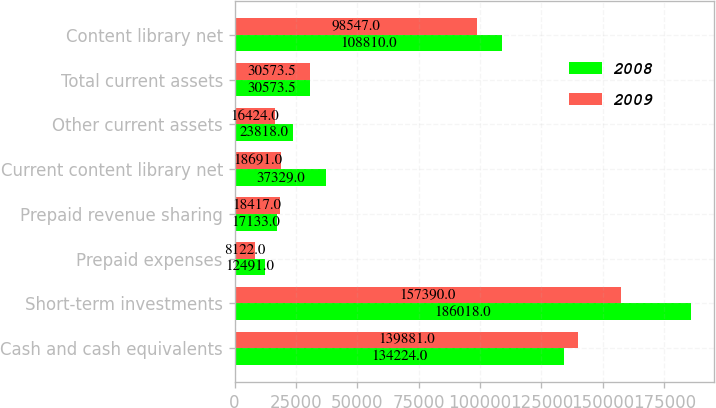<chart> <loc_0><loc_0><loc_500><loc_500><stacked_bar_chart><ecel><fcel>Cash and cash equivalents<fcel>Short-term investments<fcel>Prepaid expenses<fcel>Prepaid revenue sharing<fcel>Current content library net<fcel>Other current assets<fcel>Total current assets<fcel>Content library net<nl><fcel>2008<fcel>134224<fcel>186018<fcel>12491<fcel>17133<fcel>37329<fcel>23818<fcel>30573.5<fcel>108810<nl><fcel>2009<fcel>139881<fcel>157390<fcel>8122<fcel>18417<fcel>18691<fcel>16424<fcel>30573.5<fcel>98547<nl></chart> 